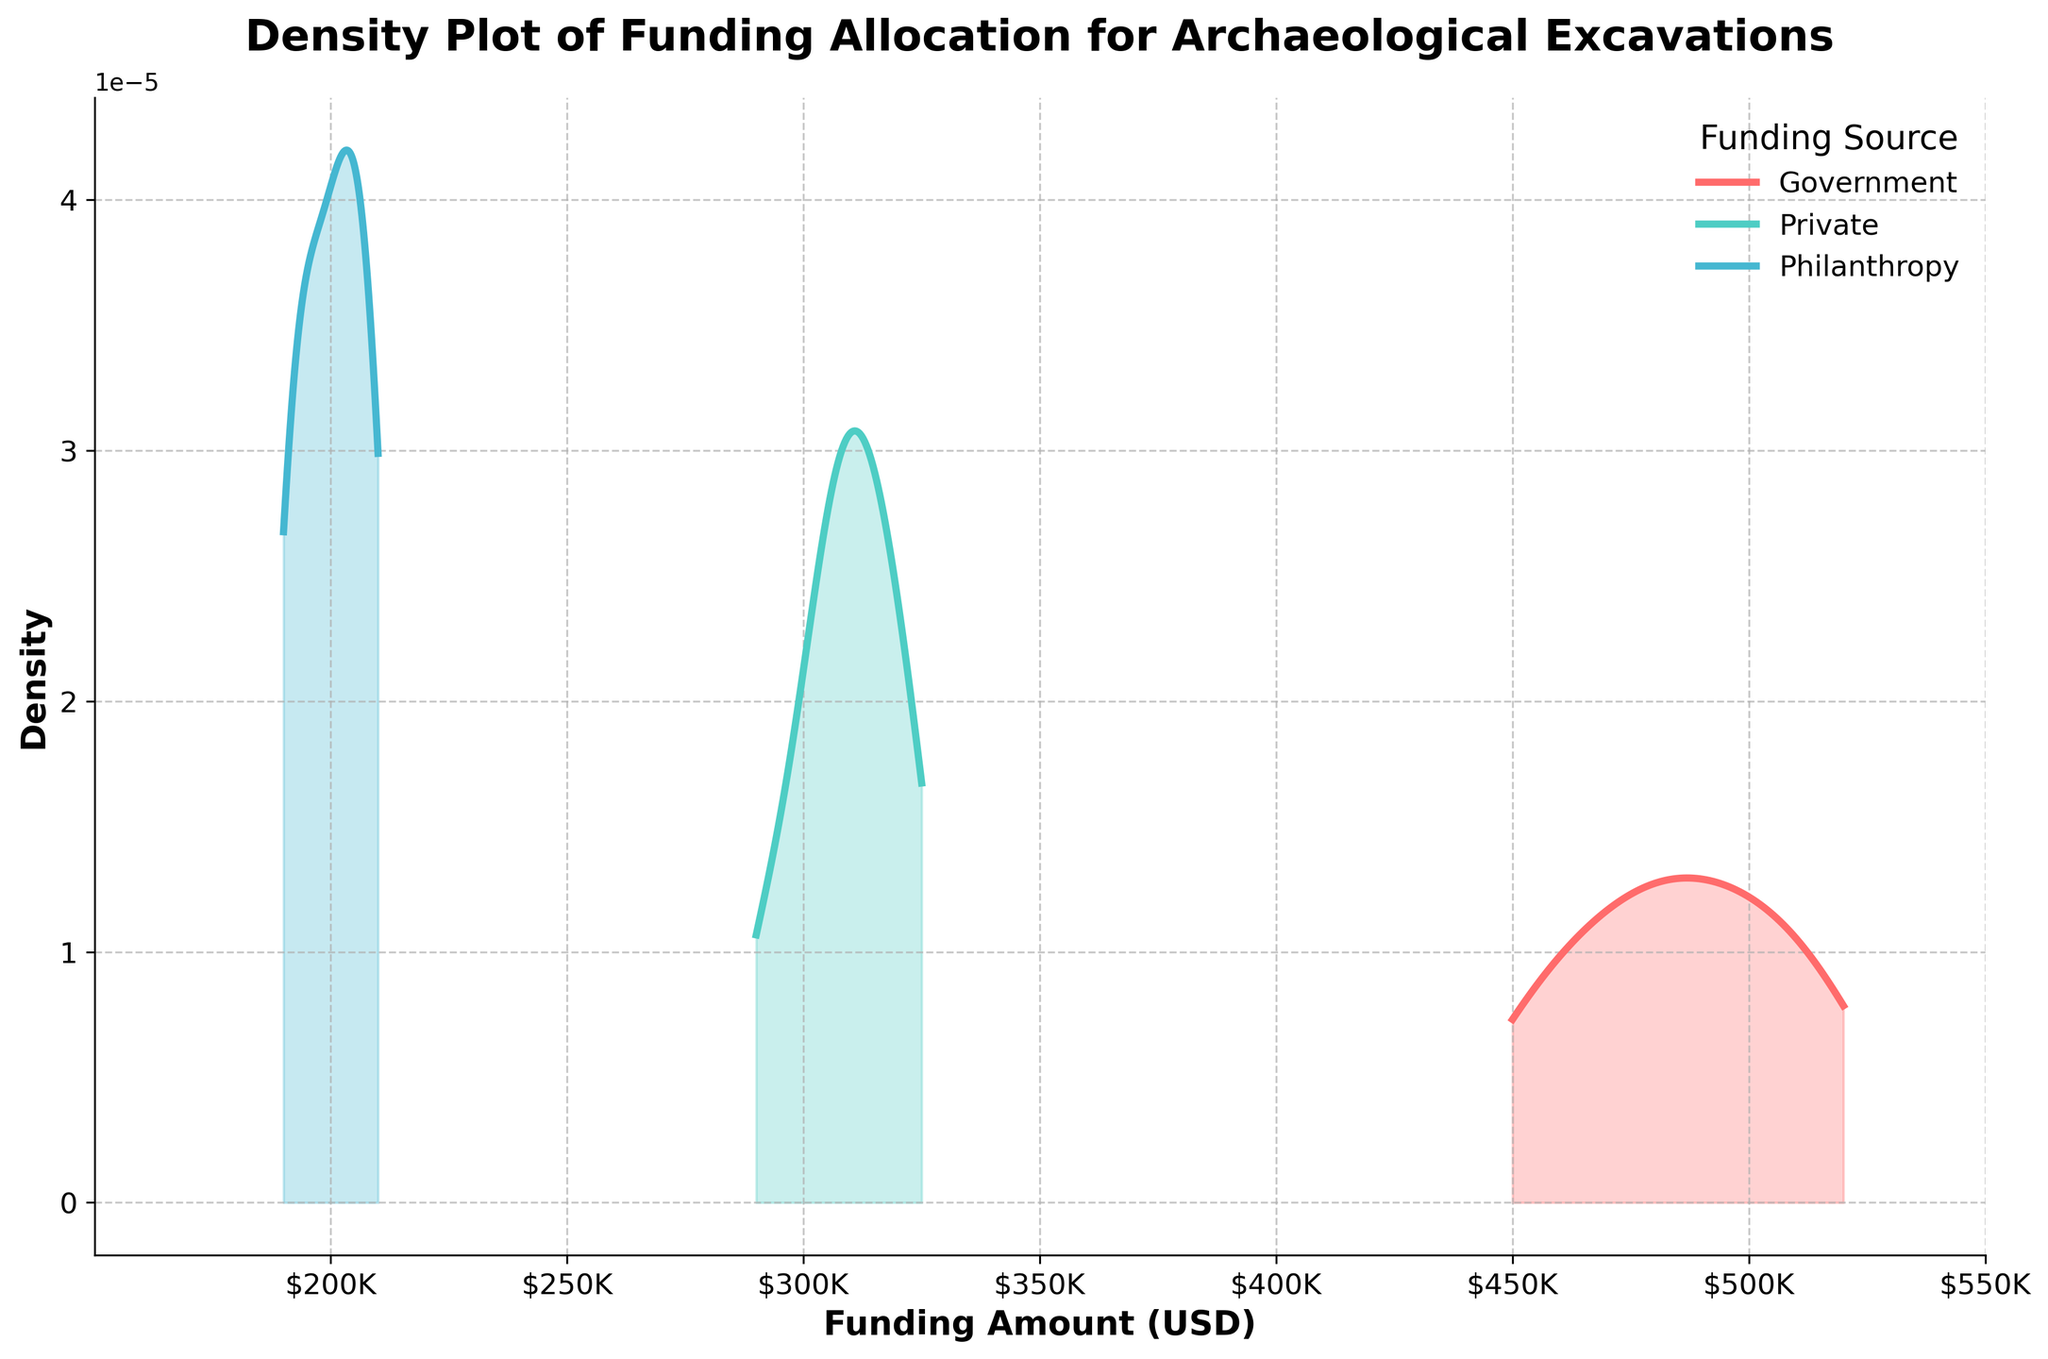What is the title of the plot? The title is displayed at the top of the plot and reads "Density Plot of Funding Allocation for Archaeological Excavations".
Answer: Density Plot of Funding Allocation for Archaeological Excavations Which source has the widest range of funding amounts in this plot? The range of a density plot can be inferred by observing the spread along the x-axis. The Government funding ranges from $450K to $520K, Private from $290K to $325K, and Philanthropy from $190K to $210K.
Answer: Government What are the funding amount intervals marked on the x-axis? The x-axis ticks are labeled from $200,000 to $550,000 and increment by $50,000 each. These labels are formatted as $K units.
Answer: $200K, $250K, $300K, $350K, $400K, $450K, $500K, $550K Which funding source shows the highest peak density? The peak density is the highest point of the density curve. By observing the plot, the Government curve has the highest peak compared to Private and Philanthropy.
Answer: Government Between Private and Philanthropy, which funding source has a higher density for amounts around $300,000? To compare density at specific funding amounts, we observe the height of the density curves near $300,000. The Private funding density curve is higher than the Philanthropy density curve around this value.
Answer: Private What is the approximate funding amount where the density for Government funding is the lowest? The lowest density point will be the minimum value on the Government density curve. Visually, the lowest point appears to be closer to $450,000 and $520,000.
Answer: $450,000 Which funding source has a density curve that forms two peaks? A curve with multiple peaks indicates a multimodal distribution. The Private funding density curve shows two distinct peaks.
Answer: Private At approximately what funding amount do all three density curves overlap? To find where all curves overlap, examine the plot for intersections of all three curves. The overlap appears to occur around the $300,000 mark.
Answer: $300,000 What is the color for the Philanthropy funding density curve? Each curve is uniquely colored. The Philanthropy curve is represented in a lighter shade, specifically blue.
Answer: Blue Between $200,000 and $250,000, which funding source has a nonzero density? A nonzero density implies the curve is above the horizontal axis in this range. Only the Philanthropy funding source has a density in this interval.
Answer: Philanthropy 